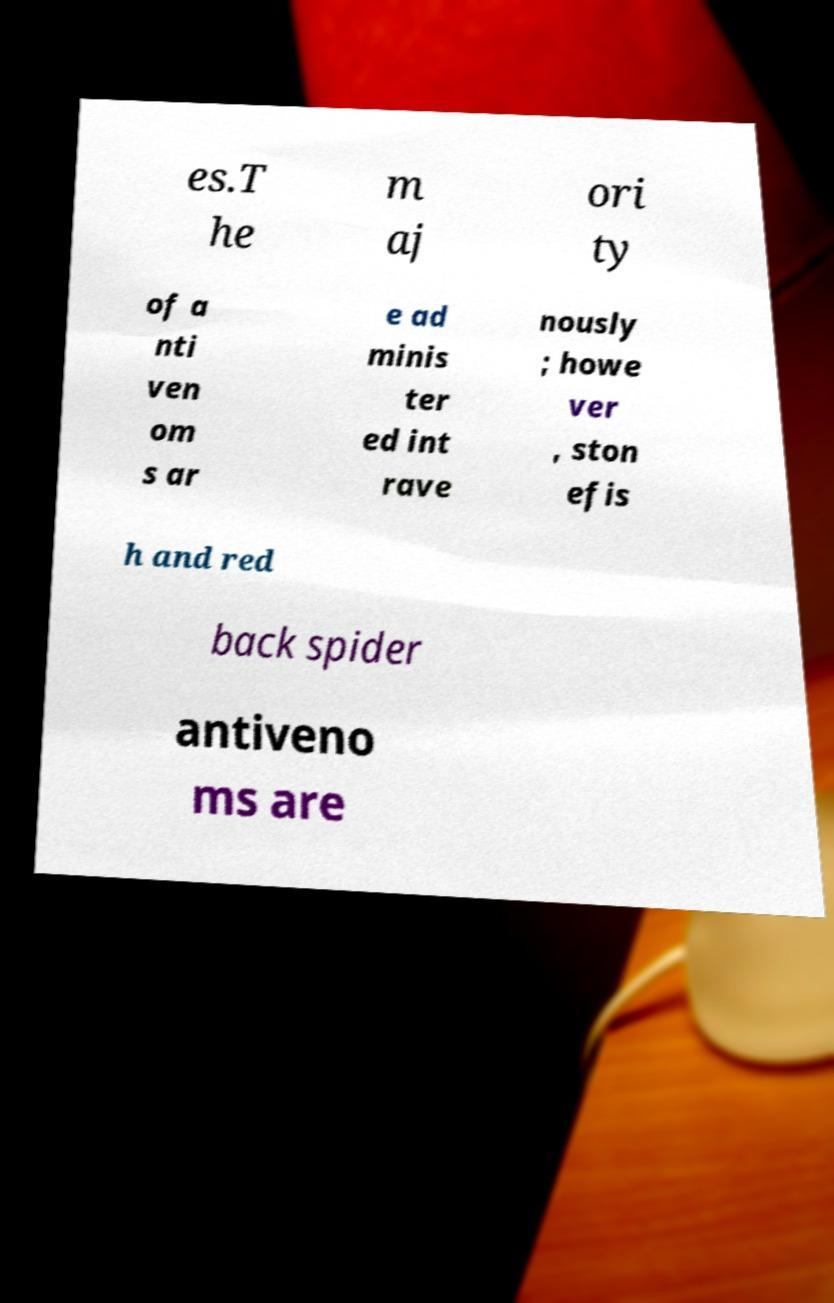Could you extract and type out the text from this image? es.T he m aj ori ty of a nti ven om s ar e ad minis ter ed int rave nously ; howe ver , ston efis h and red back spider antiveno ms are 